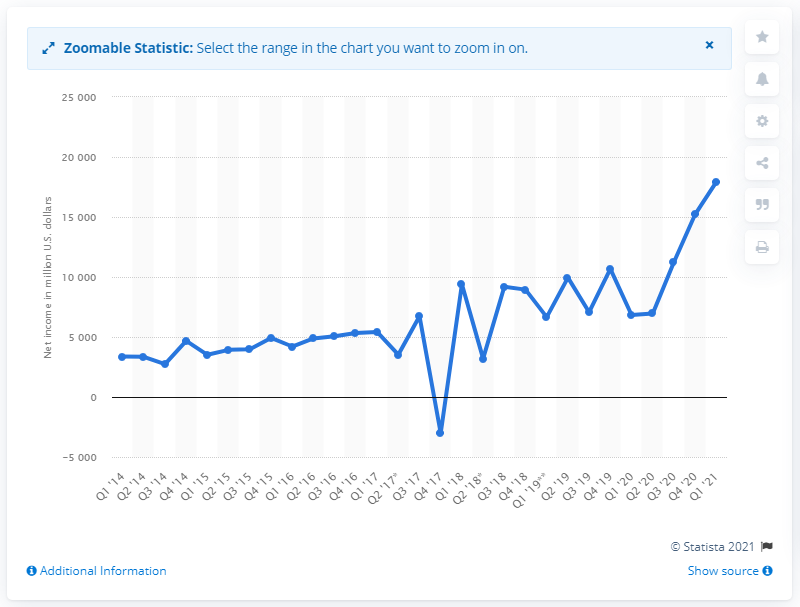Outline some significant characteristics in this image. Alphabet, the parent company of Google, reported a net income of 17,930 in the first quarter of 2021. 